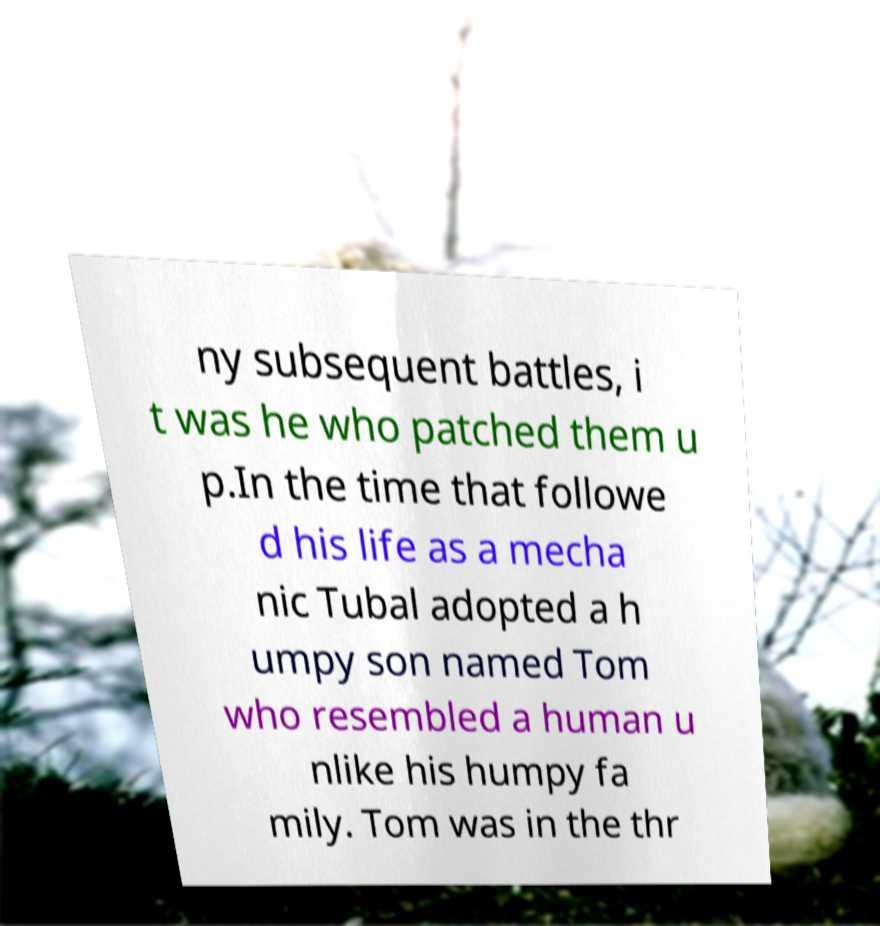Can you read and provide the text displayed in the image?This photo seems to have some interesting text. Can you extract and type it out for me? ny subsequent battles, i t was he who patched them u p.In the time that followe d his life as a mecha nic Tubal adopted a h umpy son named Tom who resembled a human u nlike his humpy fa mily. Tom was in the thr 